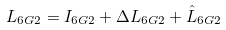<formula> <loc_0><loc_0><loc_500><loc_500>L _ { 6 G 2 } & = I _ { 6 G 2 } + \Delta L _ { 6 G 2 } + \hat { L } _ { 6 G 2 }</formula> 